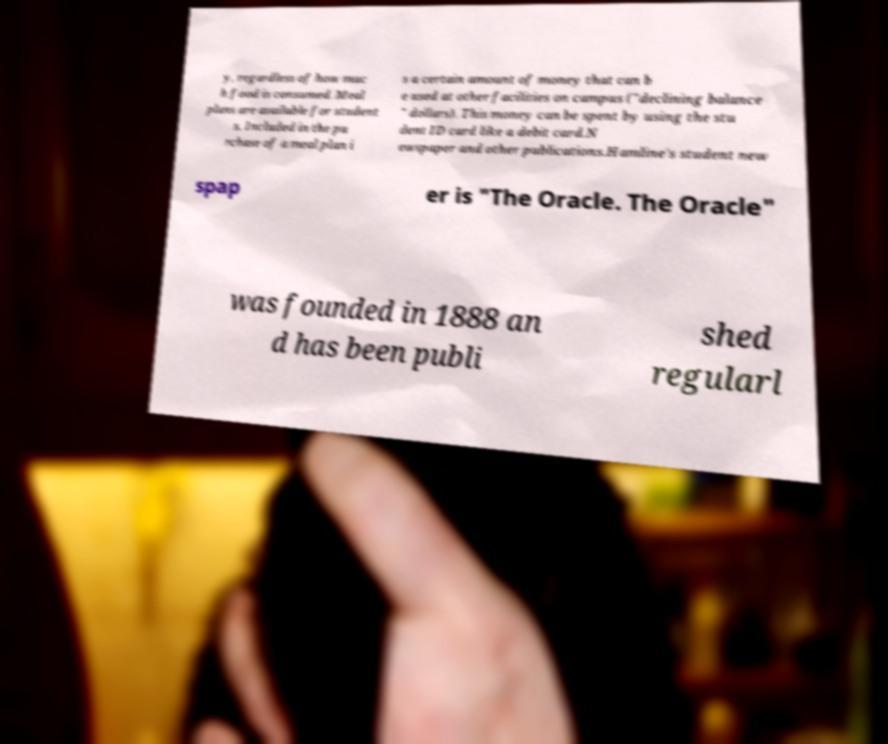I need the written content from this picture converted into text. Can you do that? y, regardless of how muc h food is consumed. Meal plans are available for student s. Included in the pu rchase of a meal plan i s a certain amount of money that can b e used at other facilities on campus ("declining balance " dollars). This money can be spent by using the stu dent ID card like a debit card.N ewspaper and other publications.Hamline's student new spap er is "The Oracle. The Oracle" was founded in 1888 an d has been publi shed regularl 